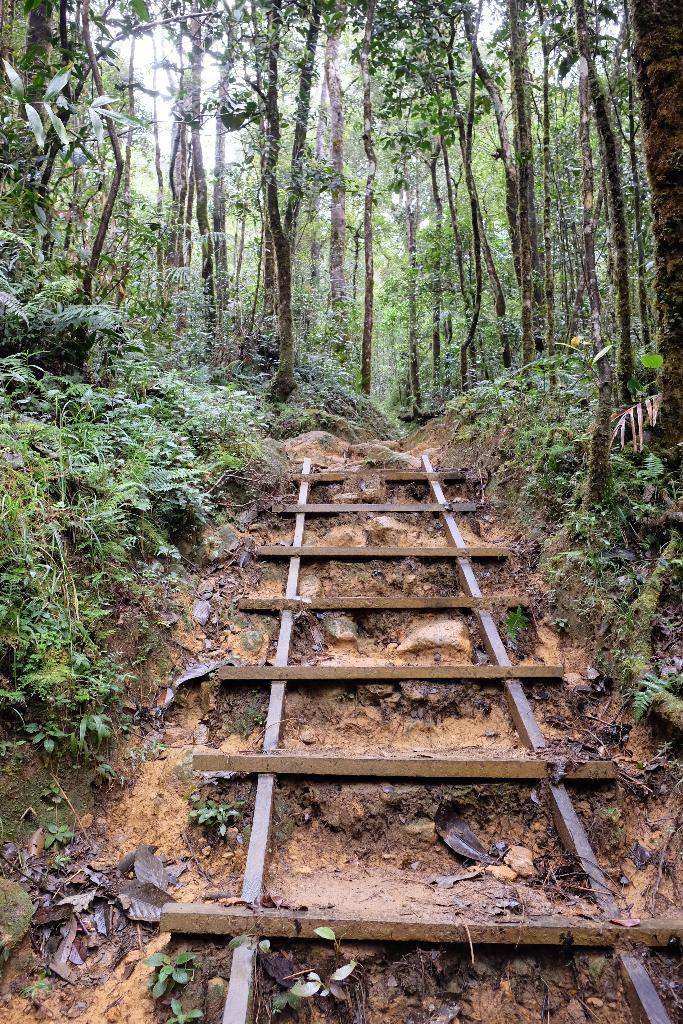What type of environment is depicted in the image? The image shows an inside view of a forest. What can be found in abundance in the forest? There are many trees and plants in the forest. Can you describe a specific object in the middle of the image? Yes, there is a ladder in the middle of the image. What type of question is being asked in the image? There is no question being asked in the image; it shows an inside view of a forest with trees, plants, and a ladder. Can you tell me how many pans are hanging on the trees in the image? There are no pans present in the image; it features an inside view of a forest with trees, plants, and a ladder. 